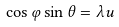<formula> <loc_0><loc_0><loc_500><loc_500>\cos { \varphi } \sin { \theta } = \lambda u</formula> 